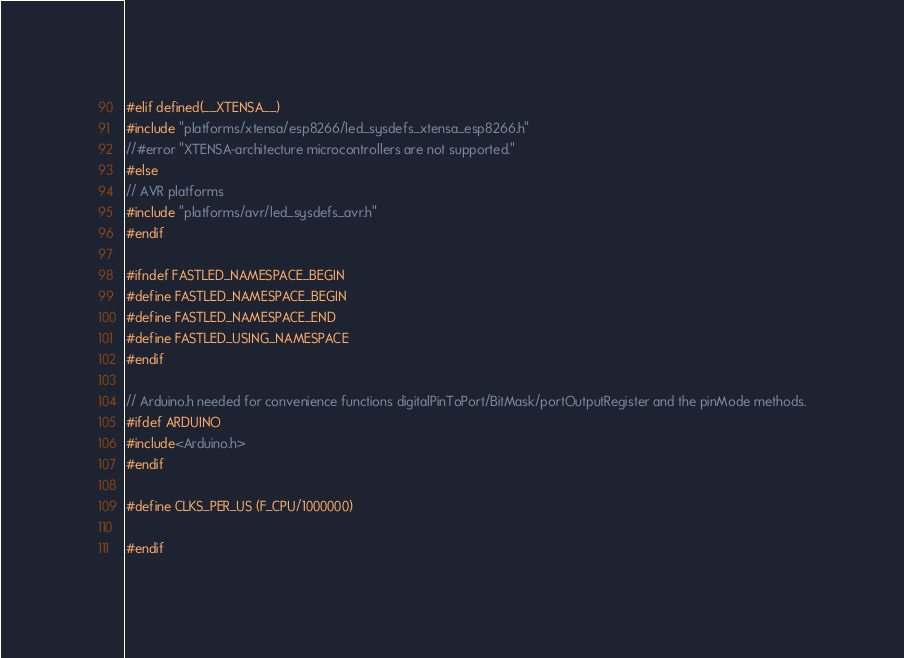<code> <loc_0><loc_0><loc_500><loc_500><_C_>#elif defined(__XTENSA__)
#include "platforms/xtensa/esp8266/led_sysdefs_xtensa_esp8266.h"
//#error "XTENSA-architecture microcontrollers are not supported."
#else
// AVR platforms
#include "platforms/avr/led_sysdefs_avr.h"
#endif

#ifndef FASTLED_NAMESPACE_BEGIN
#define FASTLED_NAMESPACE_BEGIN
#define FASTLED_NAMESPACE_END
#define FASTLED_USING_NAMESPACE
#endif

// Arduino.h needed for convenience functions digitalPinToPort/BitMask/portOutputRegister and the pinMode methods.
#ifdef ARDUINO
#include<Arduino.h>
#endif

#define CLKS_PER_US (F_CPU/1000000)

#endif
</code> 